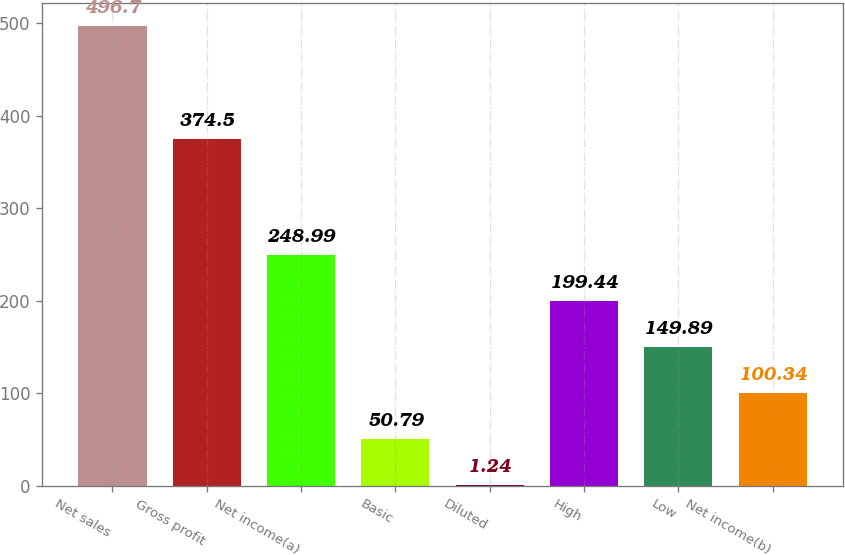<chart> <loc_0><loc_0><loc_500><loc_500><bar_chart><fcel>Net sales<fcel>Gross profit<fcel>Net income(a)<fcel>Basic<fcel>Diluted<fcel>High<fcel>Low<fcel>Net income(b)<nl><fcel>496.7<fcel>374.5<fcel>248.99<fcel>50.79<fcel>1.24<fcel>199.44<fcel>149.89<fcel>100.34<nl></chart> 